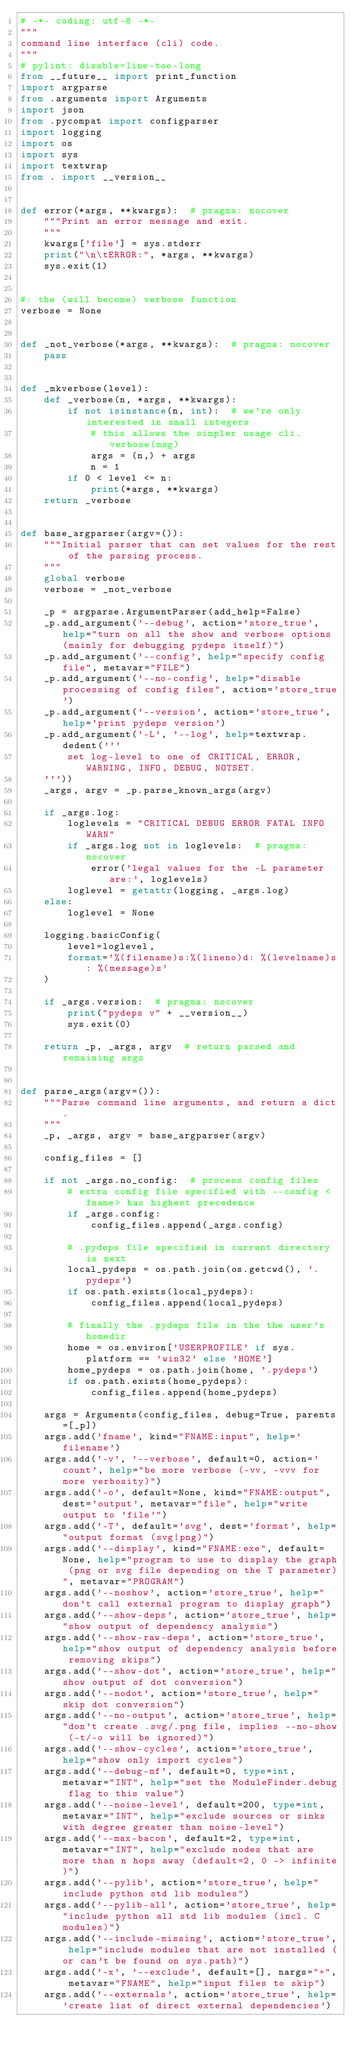Convert code to text. <code><loc_0><loc_0><loc_500><loc_500><_Python_># -*- coding: utf-8 -*-
"""
command line interface (cli) code.
"""
# pylint: disable=line-too-long
from __future__ import print_function
import argparse
from .arguments import Arguments
import json
from .pycompat import configparser
import logging
import os
import sys
import textwrap
from . import __version__


def error(*args, **kwargs):  # pragma: nocover
    """Print an error message and exit.
    """
    kwargs['file'] = sys.stderr
    print("\n\tERROR:", *args, **kwargs)
    sys.exit(1)


#: the (will become) verbose function
verbose = None


def _not_verbose(*args, **kwargs):  # pragma: nocover
    pass


def _mkverbose(level):
    def _verbose(n, *args, **kwargs):
        if not isinstance(n, int):  # we're only interested in small integers
            # this allows the simpler usage cli.verbose(msg)
            args = (n,) + args
            n = 1
        if 0 < level <= n:
            print(*args, **kwargs)
    return _verbose


def base_argparser(argv=()):
    """Initial parser that can set values for the rest of the parsing process.
    """
    global verbose
    verbose = _not_verbose

    _p = argparse.ArgumentParser(add_help=False)
    _p.add_argument('--debug', action='store_true', help="turn on all the show and verbose options (mainly for debugging pydeps itself)")
    _p.add_argument('--config', help="specify config file", metavar="FILE")
    _p.add_argument('--no-config', help="disable processing of config files", action='store_true')
    _p.add_argument('--version', action='store_true', help='print pydeps version')
    _p.add_argument('-L', '--log', help=textwrap.dedent('''
        set log-level to one of CRITICAL, ERROR, WARNING, INFO, DEBUG, NOTSET.
    '''))
    _args, argv = _p.parse_known_args(argv)

    if _args.log:
        loglevels = "CRITICAL DEBUG ERROR FATAL INFO WARN"
        if _args.log not in loglevels:  # pragma: nocover
            error('legal values for the -L parameter are:', loglevels)
        loglevel = getattr(logging, _args.log)
    else:
        loglevel = None

    logging.basicConfig(
        level=loglevel,
        format='%(filename)s:%(lineno)d: %(levelname)s: %(message)s'
    )

    if _args.version:  # pragma: nocover
        print("pydeps v" + __version__)
        sys.exit(0)

    return _p, _args, argv  # return parsed and remaining args


def parse_args(argv=()):
    """Parse command line arguments, and return a dict.
    """
    _p, _args, argv = base_argparser(argv)

    config_files = []

    if not _args.no_config:  # process config files
        # extra config file specified with --config <fname> has highest precedence
        if _args.config:
            config_files.append(_args.config)

        # .pydeps file specified in current directory is next
        local_pydeps = os.path.join(os.getcwd(), '.pydeps')
        if os.path.exists(local_pydeps):
            config_files.append(local_pydeps)

        # finally the .pydeps file in the the user's homedir
        home = os.environ['USERPROFILE' if sys.platform == 'win32' else 'HOME']
        home_pydeps = os.path.join(home, '.pydeps')
        if os.path.exists(home_pydeps):
            config_files.append(home_pydeps)
        
    args = Arguments(config_files, debug=True, parents=[_p])
    args.add('fname', kind="FNAME:input", help='filename')
    args.add('-v', '--verbose', default=0, action='count', help="be more verbose (-vv, -vvv for more verbosity)")
    args.add('-o', default=None, kind="FNAME:output", dest='output', metavar="file", help="write output to 'file'")
    args.add('-T', default='svg', dest='format', help="output format (svg|png)")
    args.add('--display', kind="FNAME:exe", default=None, help="program to use to display the graph (png or svg file depending on the T parameter)", metavar="PROGRAM")
    args.add('--noshow', action='store_true', help="don't call external program to display graph")
    args.add('--show-deps', action='store_true', help="show output of dependency analysis")
    args.add('--show-raw-deps', action='store_true', help="show output of dependency analysis before removing skips")
    args.add('--show-dot', action='store_true', help="show output of dot conversion")
    args.add('--nodot', action='store_true', help="skip dot conversion")
    args.add('--no-output', action='store_true', help="don't create .svg/.png file, implies --no-show (-t/-o will be ignored)")
    args.add('--show-cycles', action='store_true', help="show only import cycles")
    args.add('--debug-mf', default=0, type=int, metavar="INT", help="set the ModuleFinder.debug flag to this value")
    args.add('--noise-level', default=200, type=int, metavar="INT", help="exclude sources or sinks with degree greater than noise-level")
    args.add('--max-bacon', default=2, type=int, metavar="INT", help="exclude nodes that are more than n hops away (default=2, 0 -> infinite)")
    args.add('--pylib', action='store_true', help="include python std lib modules")
    args.add('--pylib-all', action='store_true', help="include python all std lib modules (incl. C modules)")
    args.add('--include-missing', action='store_true', help="include modules that are not installed (or can't be found on sys.path)")
    args.add('-x', '--exclude', default=[], nargs="+", metavar="FNAME", help="input files to skip")
    args.add('--externals', action='store_true', help='create list of direct external dependencies')</code> 